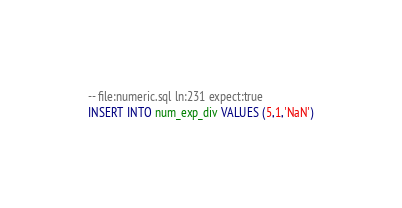Convert code to text. <code><loc_0><loc_0><loc_500><loc_500><_SQL_>-- file:numeric.sql ln:231 expect:true
INSERT INTO num_exp_div VALUES (5,1,'NaN')
</code> 